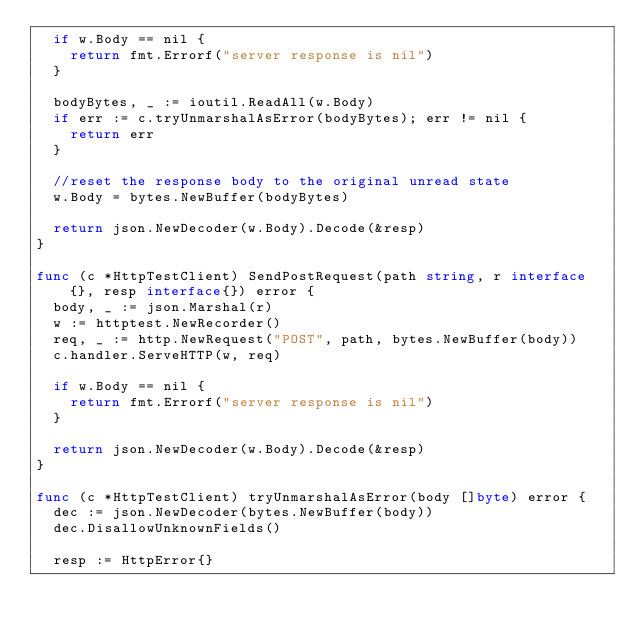<code> <loc_0><loc_0><loc_500><loc_500><_Go_>	if w.Body == nil {
		return fmt.Errorf("server response is nil")
	}

	bodyBytes, _ := ioutil.ReadAll(w.Body)
	if err := c.tryUnmarshalAsError(bodyBytes); err != nil {
		return err
	}

	//reset the response body to the original unread state
	w.Body = bytes.NewBuffer(bodyBytes)

	return json.NewDecoder(w.Body).Decode(&resp)
}

func (c *HttpTestClient) SendPostRequest(path string, r interface{}, resp interface{}) error {
	body, _ := json.Marshal(r)
	w := httptest.NewRecorder()
	req, _ := http.NewRequest("POST", path, bytes.NewBuffer(body))
	c.handler.ServeHTTP(w, req)

	if w.Body == nil {
		return fmt.Errorf("server response is nil")
	}

	return json.NewDecoder(w.Body).Decode(&resp)
}

func (c *HttpTestClient) tryUnmarshalAsError(body []byte) error {
	dec := json.NewDecoder(bytes.NewBuffer(body))
	dec.DisallowUnknownFields()

	resp := HttpError{}</code> 